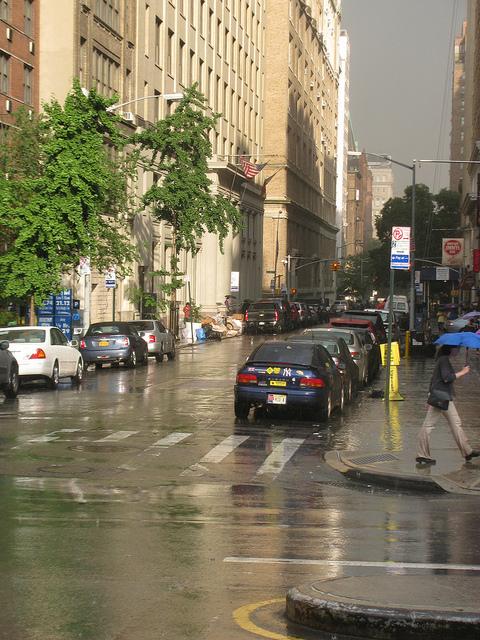What kind of weather just passed through the area?
Answer briefly. Rain. Are the streets wet?
Quick response, please. Yes. Is it daytime?
Answer briefly. Yes. 